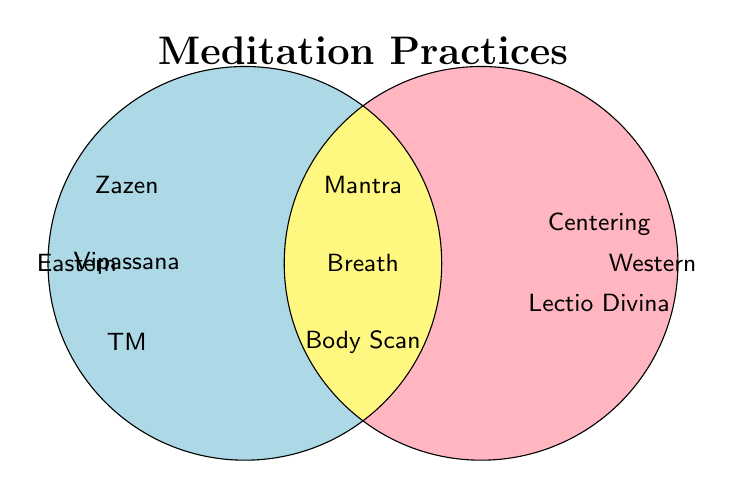What's the title of the figure? The title is located at the top of the figure, typically in a bold or large font.
Answer: Meditation Practices Which meditation practices are only found in Eastern traditions? The figure lists practices specific to Eastern traditions within the left circle labeled "Eastern."
Answer: Zazen, Vipassana, TM Which practices are common to both Eastern and Western traditions? Practices found within the overlapping section of the two circles represent those common to both traditions.
Answer: Mantra, Breath, Body Scan How many unique meditation practices are listed in total? Count all the practices shown within the figures' circles, including ones in the overlapping section.
Answer: 8 Which tradition has more unique practices, excluding those shared with the other tradition? Compare the counts of practices in each of the specific non-overlapping sections of the circles.
Answer: Eastern Are there more practices shared between traditions or specific to one tradition alone? Compare the number of practices in the overlapping section against those in non-overlapping sections.
Answer: Specific to one Are Centering Prayer and Lectio Divina from the same tradition? Check the location of both practices within the figure to determine if they are within the same circle.
Answer: Yes What practices are listed in the Western tradition but not in the Eastern? Identify practices found only in the right circle labeled "Western."
Answer: Centering, Lectio Divina Which practice common to both traditions focuses on breath control or observation? Identify the practice in the overlapping section related to breath awareness.
Answer: Breath Which tradition lists 'Body Scan' as a practice? Determine whether 'Body Scan' appears in the sections for Eastern, Western, or both traditions.
Answer: Both 